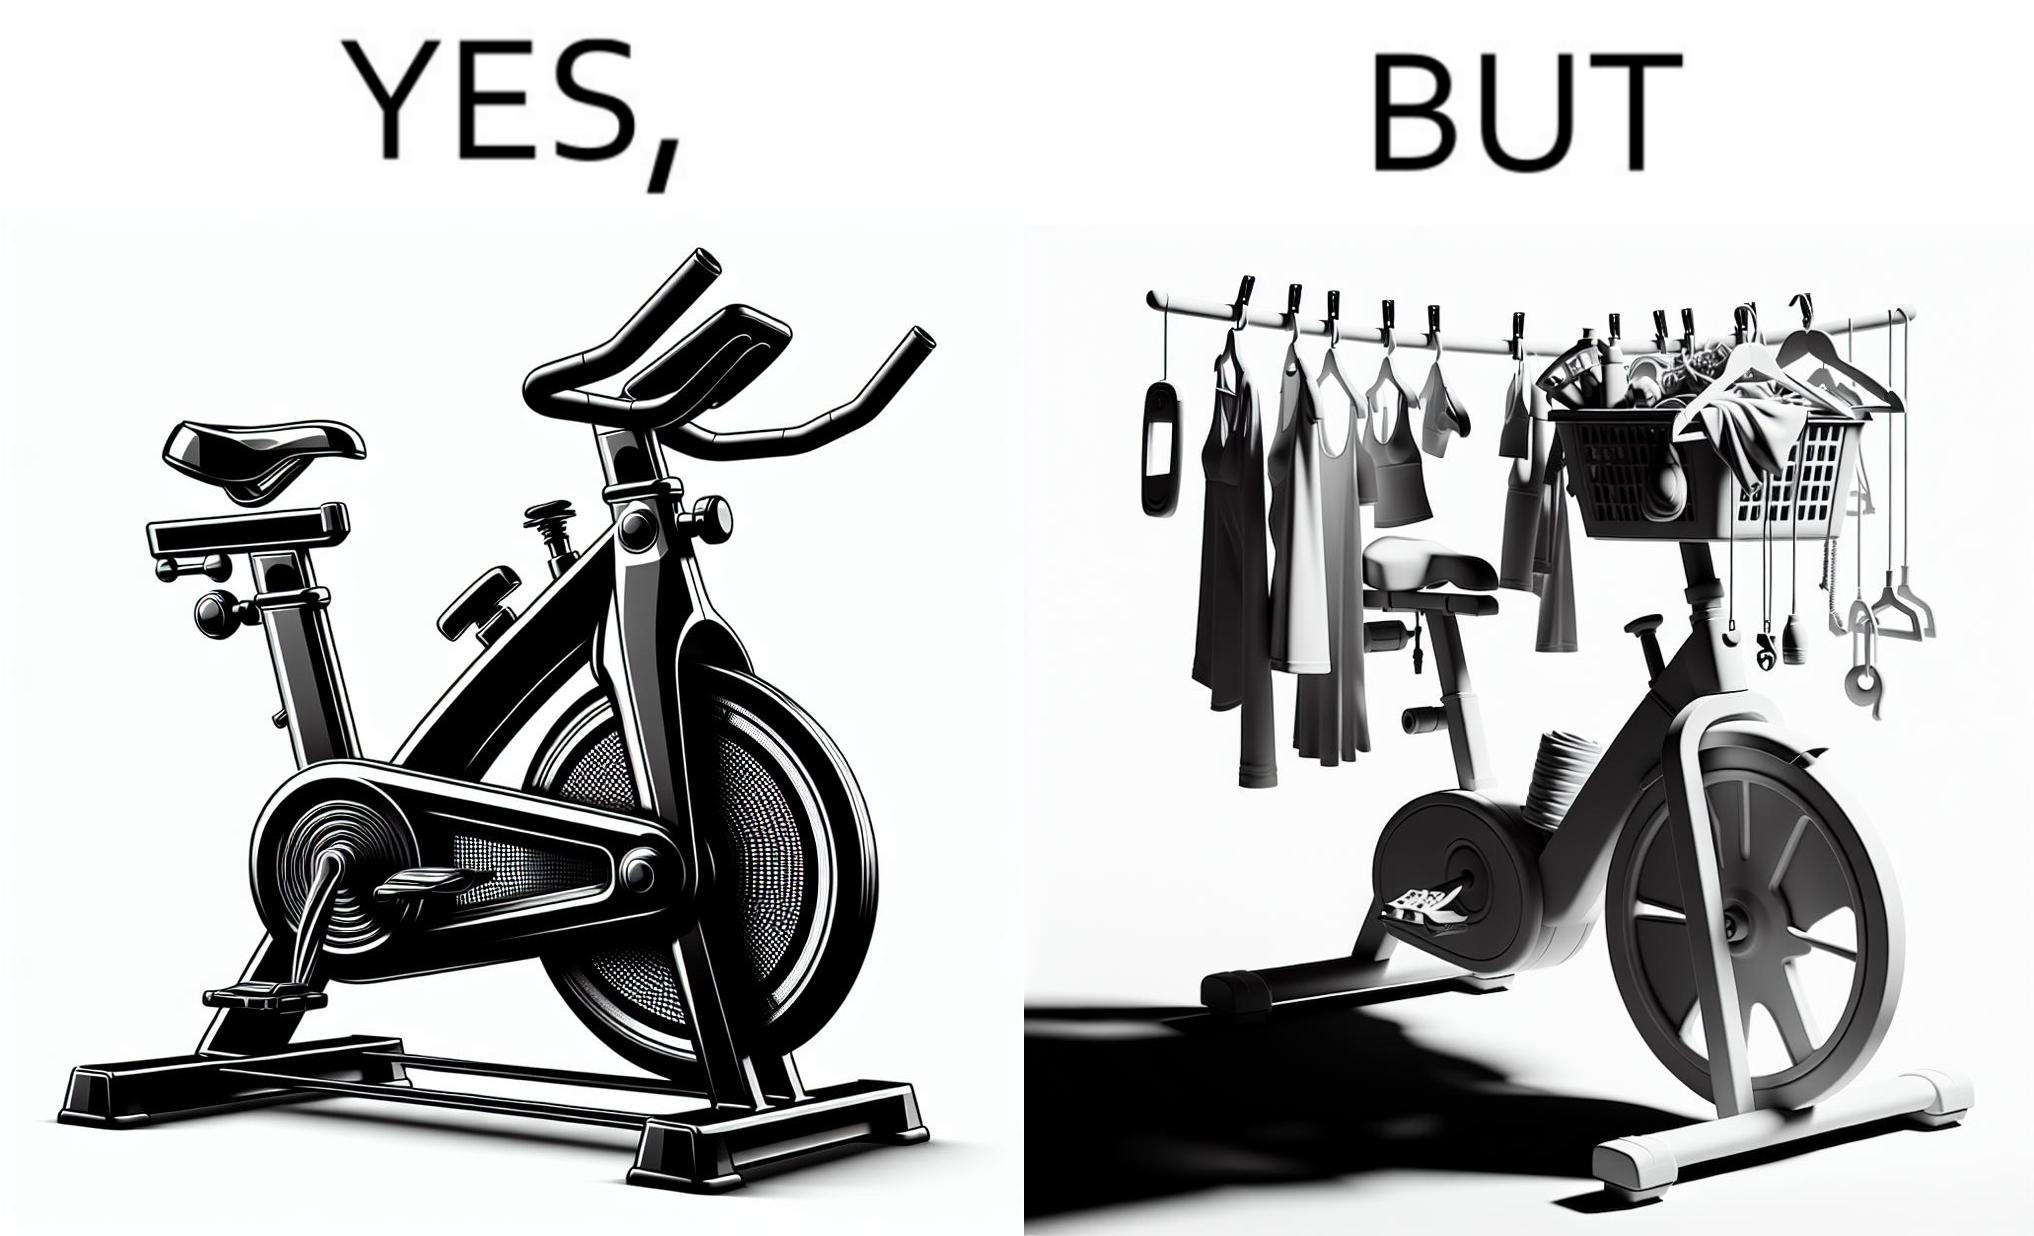Explain the humor or irony in this image. The images are funny since they show an exercise bike has been bought but is not being used for its purpose, that is, exercising. It is rather being used to hang clothes, bags and other items 